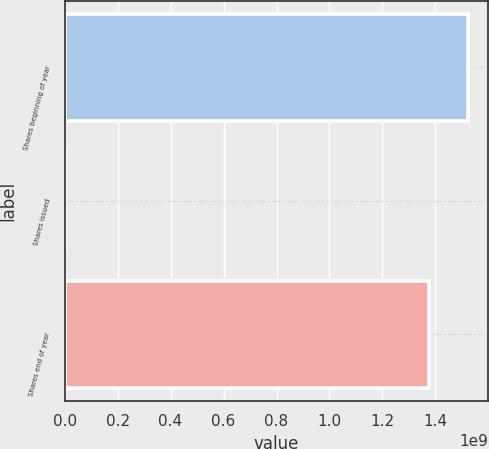<chart> <loc_0><loc_0><loc_500><loc_500><bar_chart><fcel>Shares beginning of year<fcel>Shares issued<fcel>Shares end of year<nl><fcel>1.52233e+09<fcel>41551<fcel>1.37593e+09<nl></chart> 